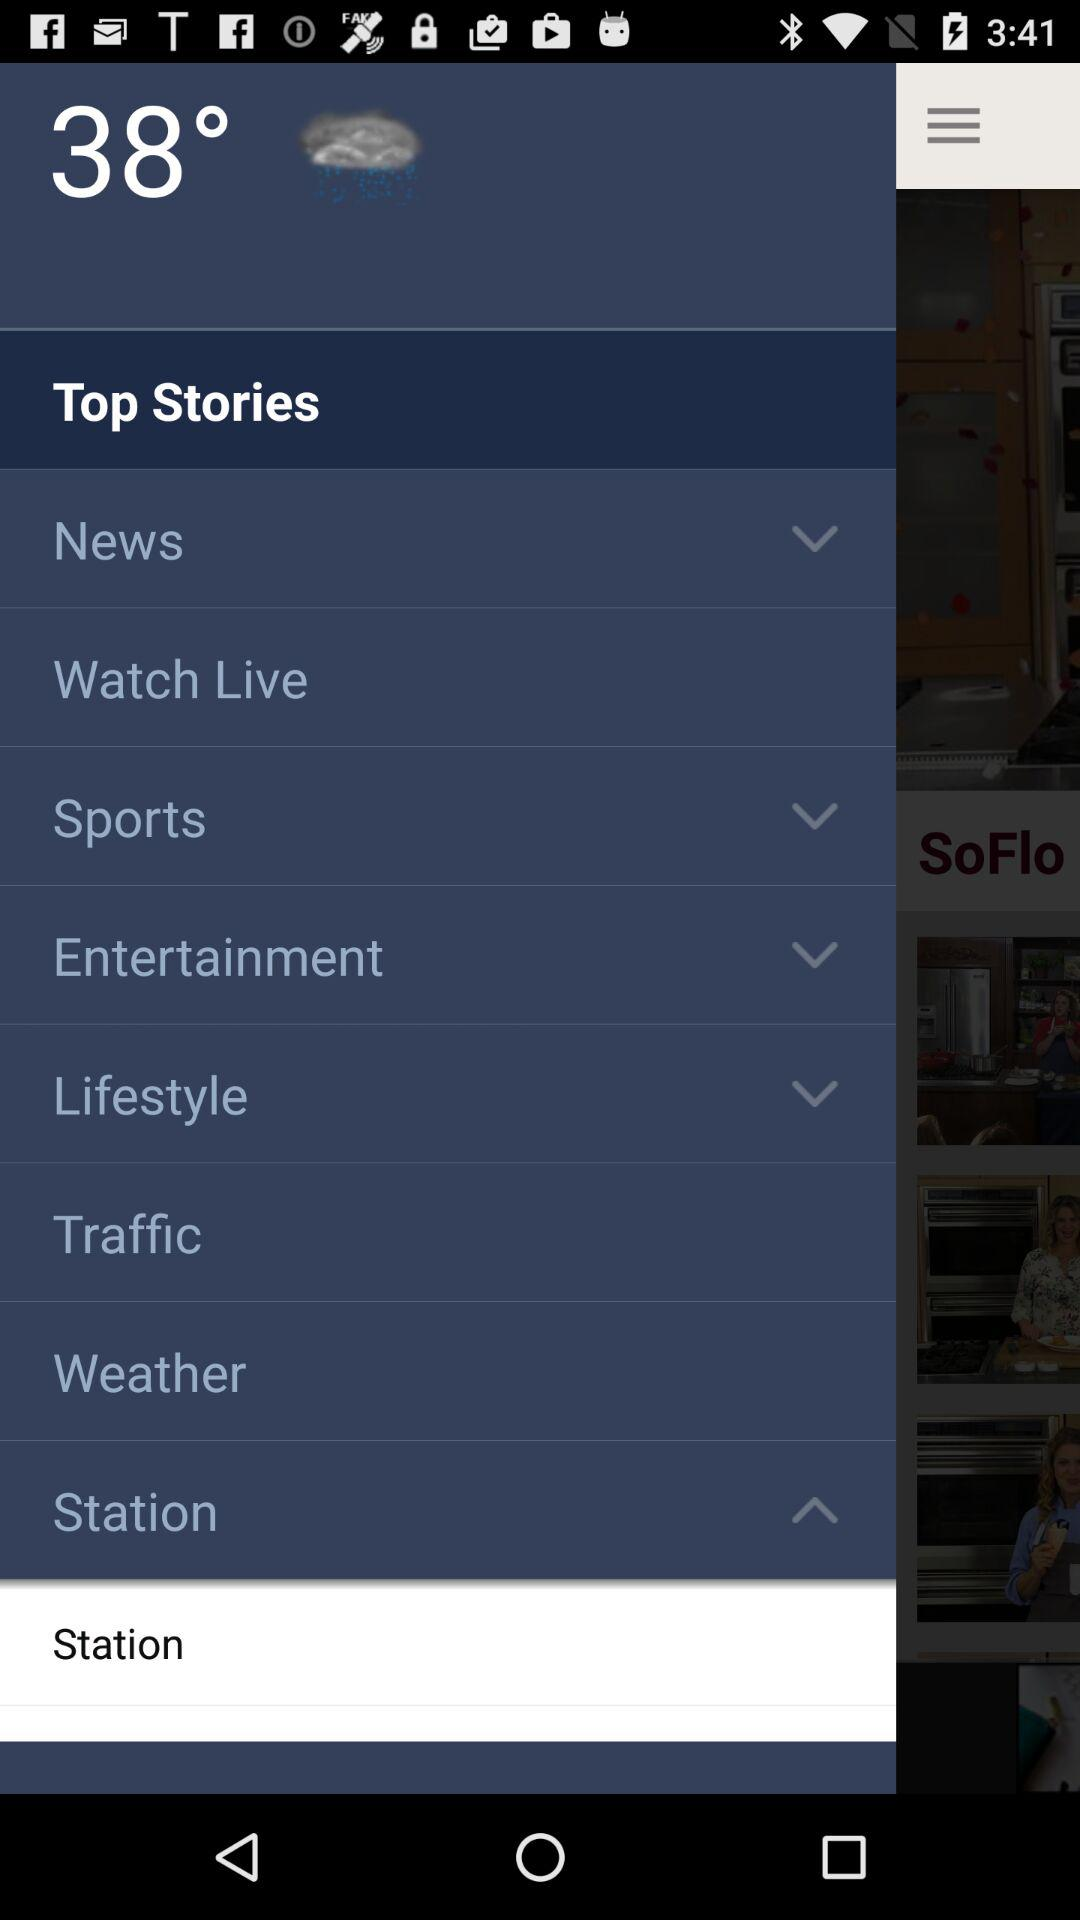What is the temperature? The temperature is 38°. 